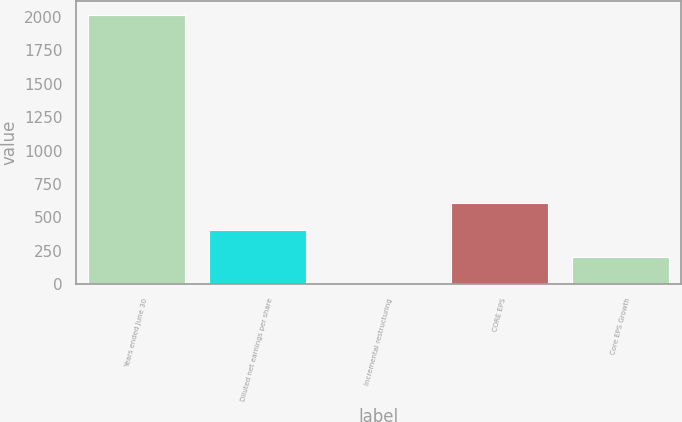Convert chart to OTSL. <chart><loc_0><loc_0><loc_500><loc_500><bar_chart><fcel>Years ended June 30<fcel>Diluted net earnings per share<fcel>Incremental restructuring<fcel>CORE EPS<fcel>Core EPS Growth<nl><fcel>2015<fcel>403.13<fcel>0.17<fcel>604.61<fcel>201.65<nl></chart> 